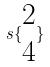Convert formula to latex. <formula><loc_0><loc_0><loc_500><loc_500>s \{ \begin{matrix} 2 \\ 4 \end{matrix} \}</formula> 